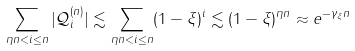<formula> <loc_0><loc_0><loc_500><loc_500>\sum _ { \eta n < i \leq n } | \mathcal { Q } ^ { ( n ) } _ { i } | \lesssim \sum _ { \eta n < i \leq n } ( 1 - \xi ) ^ { i } \lesssim ( 1 - \xi ) ^ { \eta n } \approx e ^ { - \gamma _ { \xi } n }</formula> 